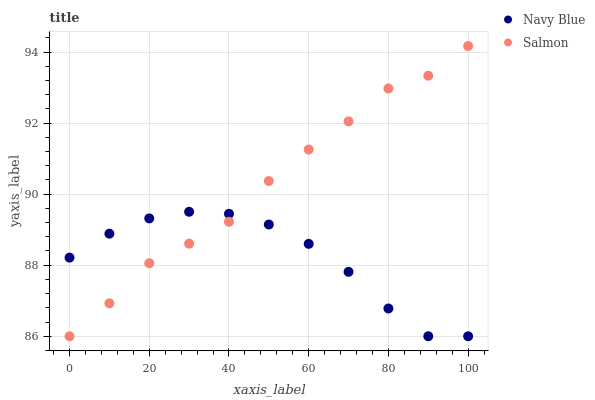Does Navy Blue have the minimum area under the curve?
Answer yes or no. Yes. Does Salmon have the maximum area under the curve?
Answer yes or no. Yes. Does Salmon have the minimum area under the curve?
Answer yes or no. No. Is Navy Blue the smoothest?
Answer yes or no. Yes. Is Salmon the roughest?
Answer yes or no. Yes. Is Salmon the smoothest?
Answer yes or no. No. Does Navy Blue have the lowest value?
Answer yes or no. Yes. Does Salmon have the highest value?
Answer yes or no. Yes. Does Salmon intersect Navy Blue?
Answer yes or no. Yes. Is Salmon less than Navy Blue?
Answer yes or no. No. Is Salmon greater than Navy Blue?
Answer yes or no. No. 